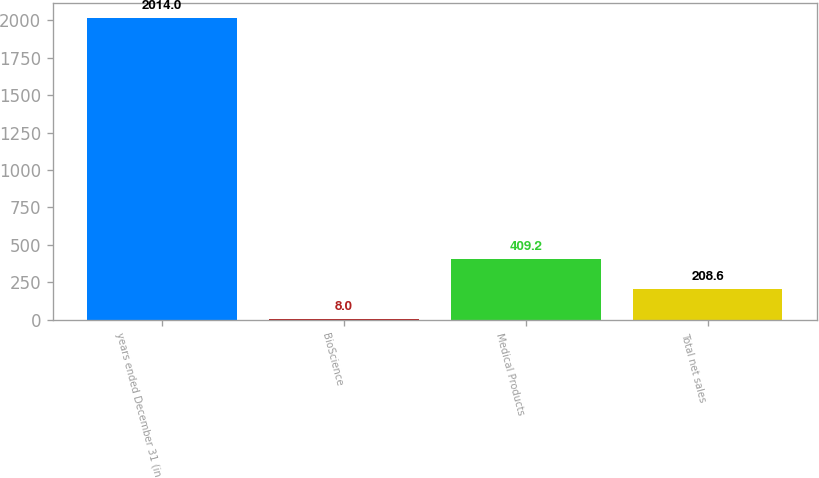Convert chart. <chart><loc_0><loc_0><loc_500><loc_500><bar_chart><fcel>years ended December 31 (in<fcel>BioScience<fcel>Medical Products<fcel>Total net sales<nl><fcel>2014<fcel>8<fcel>409.2<fcel>208.6<nl></chart> 